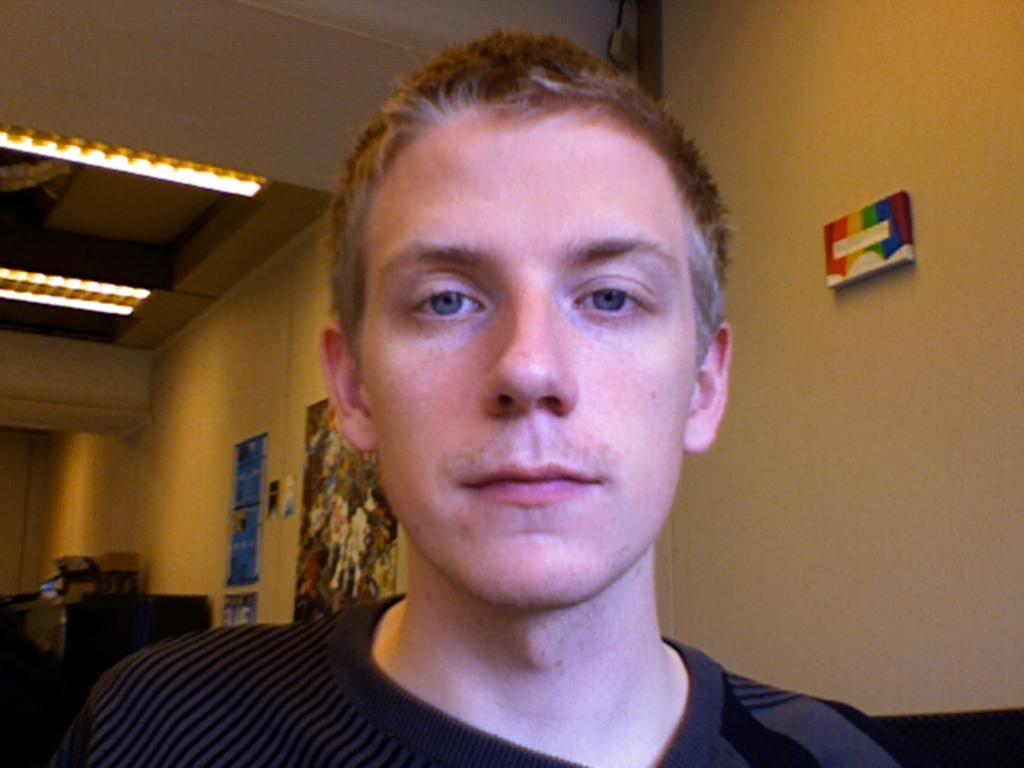What is the main subject of the image? There is a face of a man in the image. What can be seen at the top of the image? There are lights at the top of the image. What is visible in the background of the image? There is a wall in the background of the image. What is on the wall in the background? There are posters on the wall in the background. How much money is the man holding in the image? There is no money visible in the image; it only shows the face of a man and other elements in the background. 